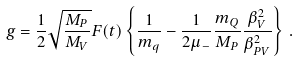Convert formula to latex. <formula><loc_0><loc_0><loc_500><loc_500>g = \frac { 1 } { 2 } \sqrt { \frac { M _ { P } } { M _ { V } } } F ( t ) \left \{ \frac { 1 } { m _ { q } } - \frac { 1 } { 2 \mu _ { - } } \frac { m _ { Q } } { M _ { P } } \frac { \beta _ { V } ^ { 2 } } { \beta _ { P V } ^ { 2 } } \right \} \, .</formula> 